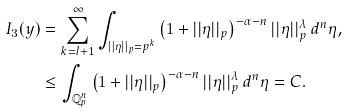Convert formula to latex. <formula><loc_0><loc_0><loc_500><loc_500>I _ { 3 } ( y ) & = \sum _ { k = l + 1 } ^ { \infty } \int _ { | | \eta | | _ { p } = p ^ { k } } \left ( 1 + | | \eta | | _ { p } \right ) ^ { - \alpha - n } | | \eta | | _ { p } ^ { \lambda } \, d ^ { n } \eta , \\ & \leq \int _ { \mathbb { Q } _ { p } ^ { n } } \left ( 1 + | | \eta | | _ { p } \right ) ^ { - \alpha - n } | | \eta | | _ { p } ^ { \lambda } \, d ^ { n } \eta = C .</formula> 